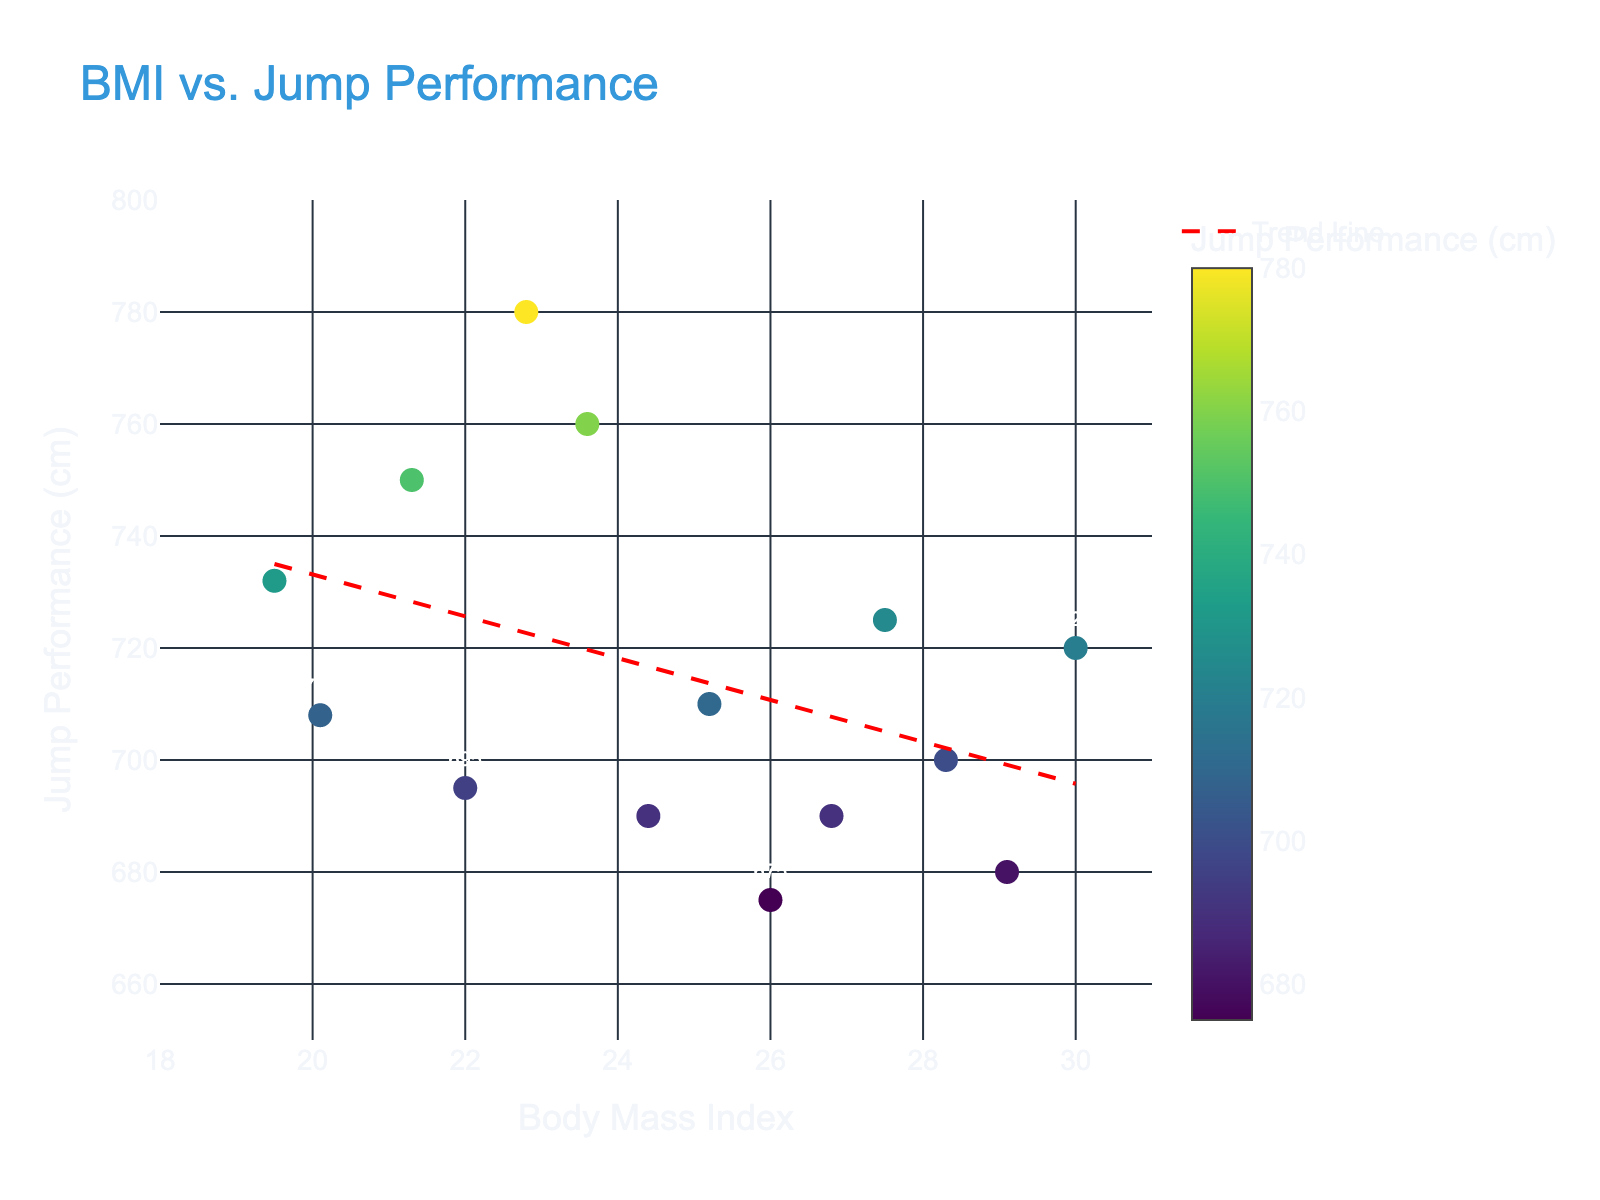What is the title of the scatter plot? The title is displayed at the top of the figure. The text reads "BMI vs. Jump Performance."
Answer: BMI vs. Jump Performance What are the variables plotted on the x-axis and y-axis? The x-axis label is "Body Mass Index" and the y-axis label is "Jump Performance (cm)," indicating that BMI is plotted on the x-axis and jump performance in centimeters is plotted on the y-axis.
Answer: Body Mass Index (x-axis) and Jump Performance (cm) (y-axis) How many data points are there in the scatter plot? By counting the points or markers present on the plot, we find there are 14 data points.
Answer: 14 What is the Jump Performance of the athlete with the highest BMI? The highest BMI is 30.0 on the x-axis, and the corresponding y-axis value is 720 cm.
Answer: 720 cm Is there a general trend between BMI and Jump Performance? By looking at the trend line added to the scatter plot, which is drawn in red and has a downward slope, we can deduce there is an inverse relationship between BMI and Jump Performance.
Answer: Inverse relationship Which athlete has the highest Jump Performance and what is their BMI? The highest point on the y-axis represents the maximum Jump Performance, which is 780 cm, and the corresponding x-axis value is 22.8 (BMI).
Answer: 22.8 BMI For BMI values between 24 and 26, do athletes typically jump more or less than 700 cm? Observing the points between the BMI values of 24 and 26 on the x-axis, we can see that the corresponding y-axis values are 690, 710, and 675 cm, which are mostly below 700 cm.
Answer: Less than 700 cm How does the Jump Performance of the athlete with a BMI of 22.0 compare to the performance of the athlete with a BMI of 25.2? The Jump Performance at a BMI of 22.0 is 695 cm, and at a BMI of 25.2 it is 710 cm. So, the athlete with a BMI of 25.2 jumps further by 15 cm.
Answer: 25.2 BMI jumps 15 cm further What is the difference in Jump Performance between the athlete with the lowest BMI and the highest BMI? The lowest BMI is 19.5 (Jump Performance = 732 cm) and the highest BMI is 30.0 (Jump Performance = 720 cm). The difference is 732 - 720 = 12 cm.
Answer: 12 cm 